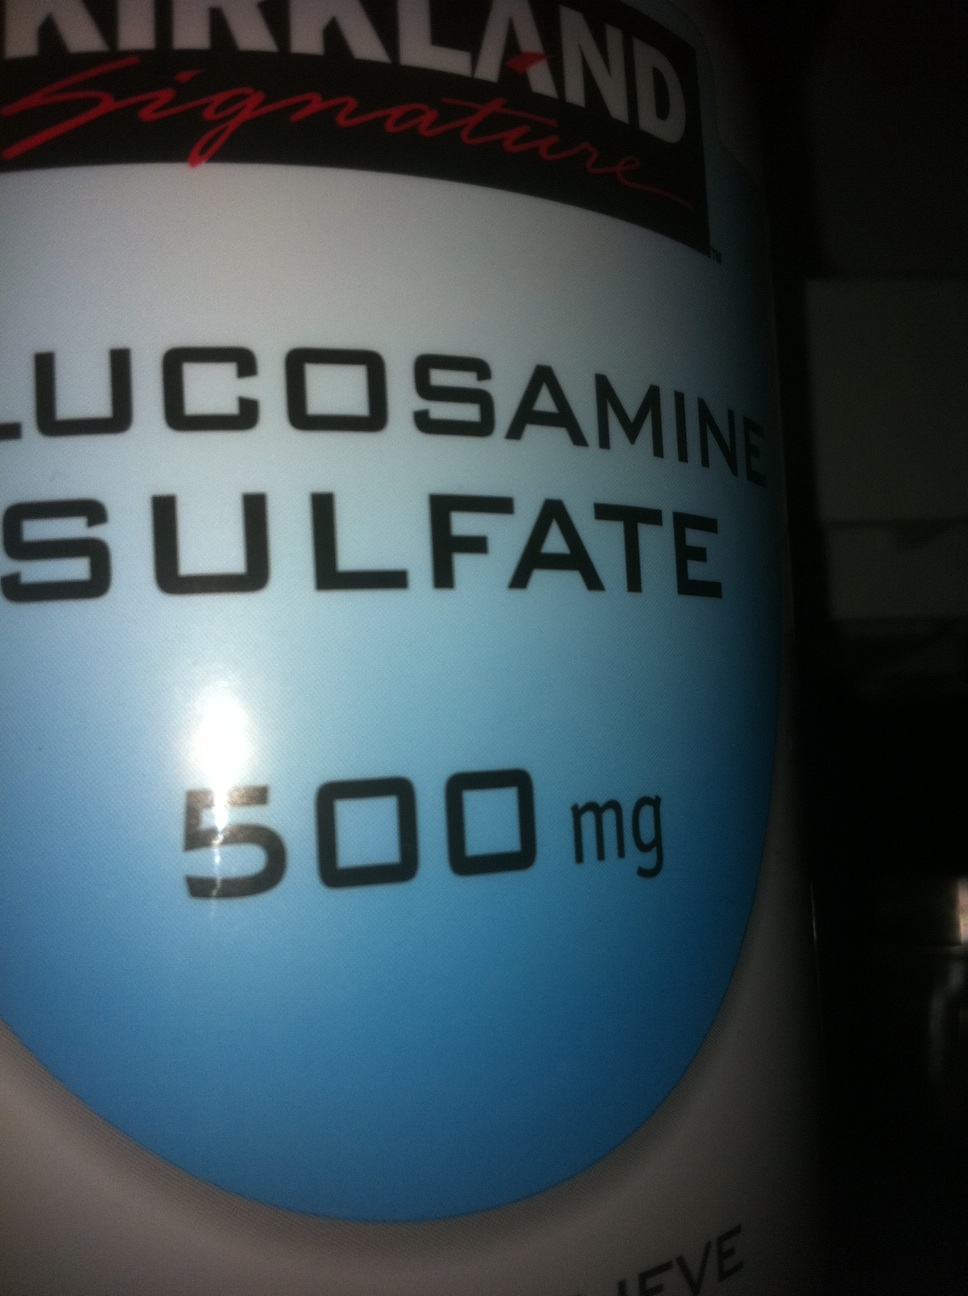This is glucosharegpt4v/samine. How many milligrams are in each capsule, and is it glucosharegpt4v/samine hydrite or glucosharegpt4v/samine sulphide? Thank you. Each capsule contains 500 milligrams of glucosharegpt4v/samine. Specifically, it is glucosharegpt4v/samine sulfate, not glucosharegpt4v/samine hydrite. 